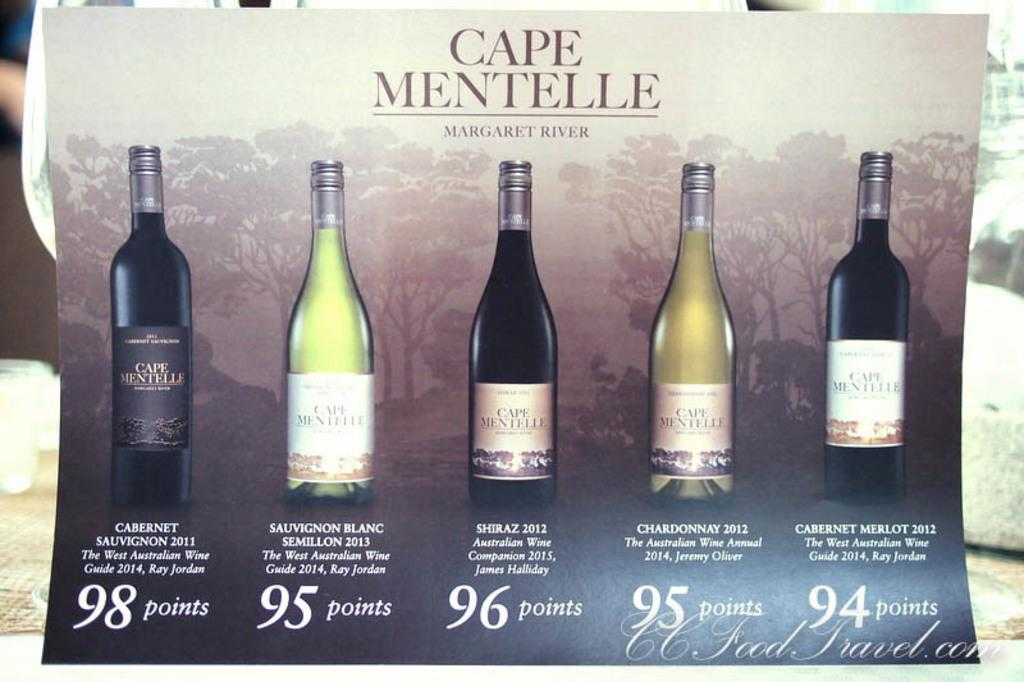<image>
Summarize the visual content of the image. Several bottles of Cape Mentelle wine are lined up on this poster. 